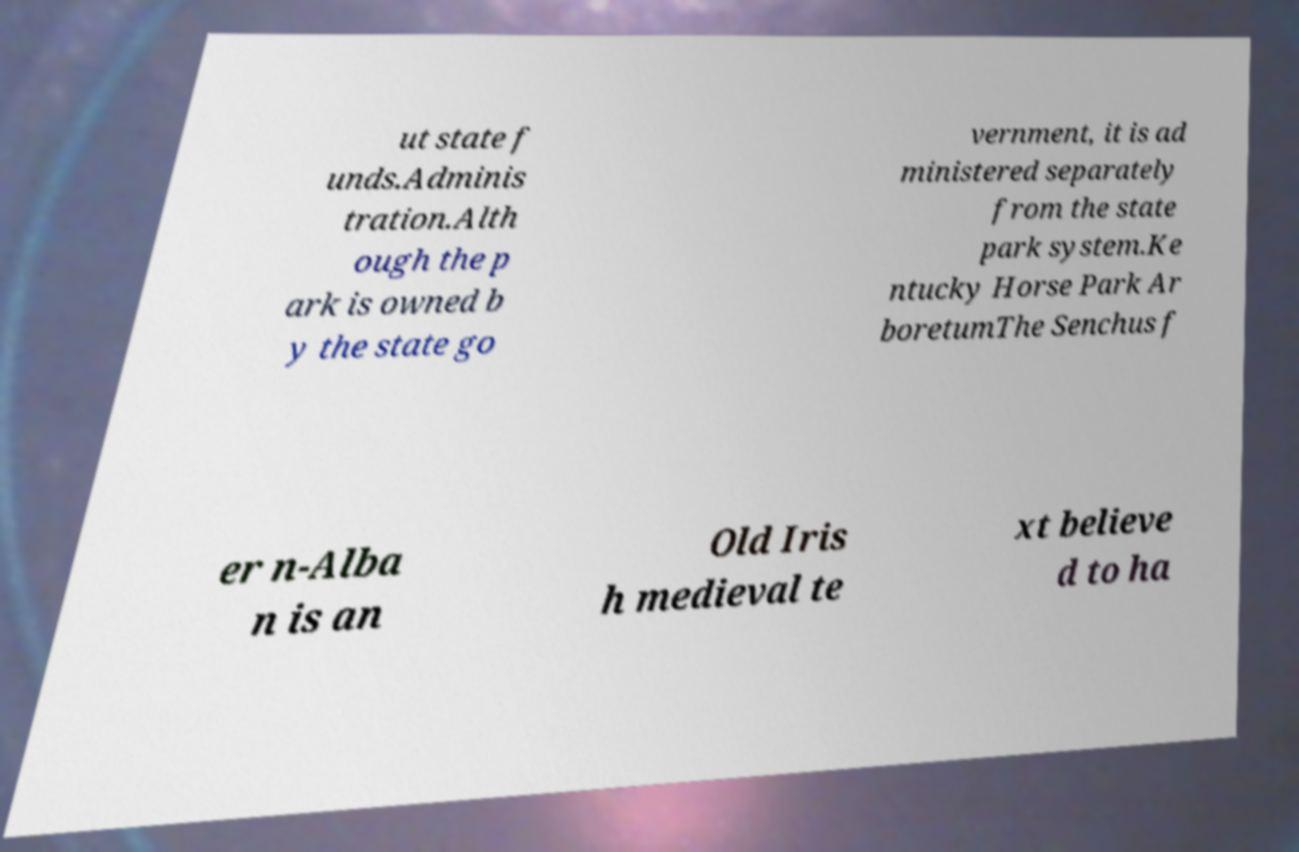There's text embedded in this image that I need extracted. Can you transcribe it verbatim? ut state f unds.Adminis tration.Alth ough the p ark is owned b y the state go vernment, it is ad ministered separately from the state park system.Ke ntucky Horse Park Ar boretumThe Senchus f er n-Alba n is an Old Iris h medieval te xt believe d to ha 